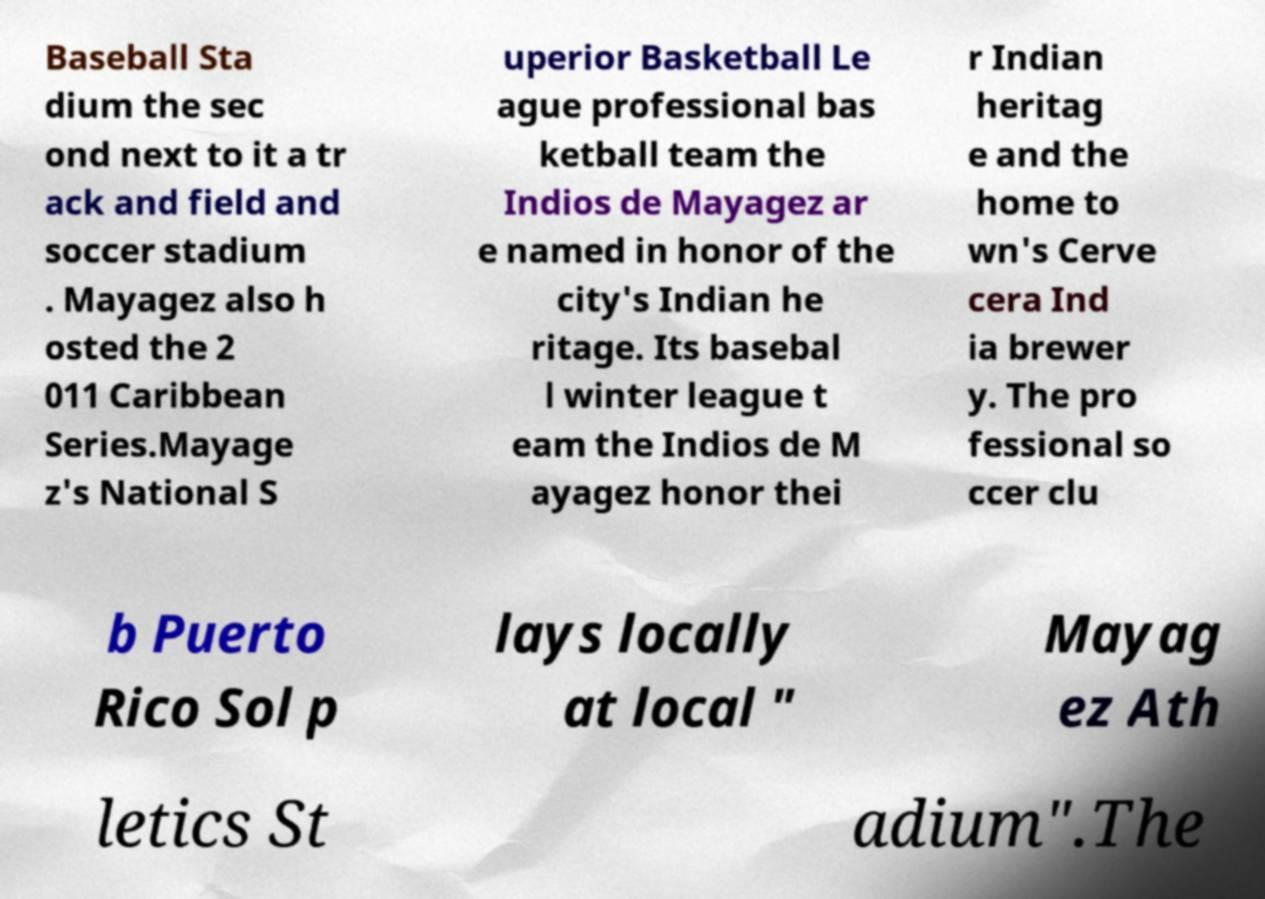What messages or text are displayed in this image? I need them in a readable, typed format. Baseball Sta dium the sec ond next to it a tr ack and field and soccer stadium . Mayagez also h osted the 2 011 Caribbean Series.Mayage z's National S uperior Basketball Le ague professional bas ketball team the Indios de Mayagez ar e named in honor of the city's Indian he ritage. Its basebal l winter league t eam the Indios de M ayagez honor thei r Indian heritag e and the home to wn's Cerve cera Ind ia brewer y. The pro fessional so ccer clu b Puerto Rico Sol p lays locally at local " Mayag ez Ath letics St adium".The 